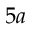<formula> <loc_0><loc_0><loc_500><loc_500>5 a</formula> 